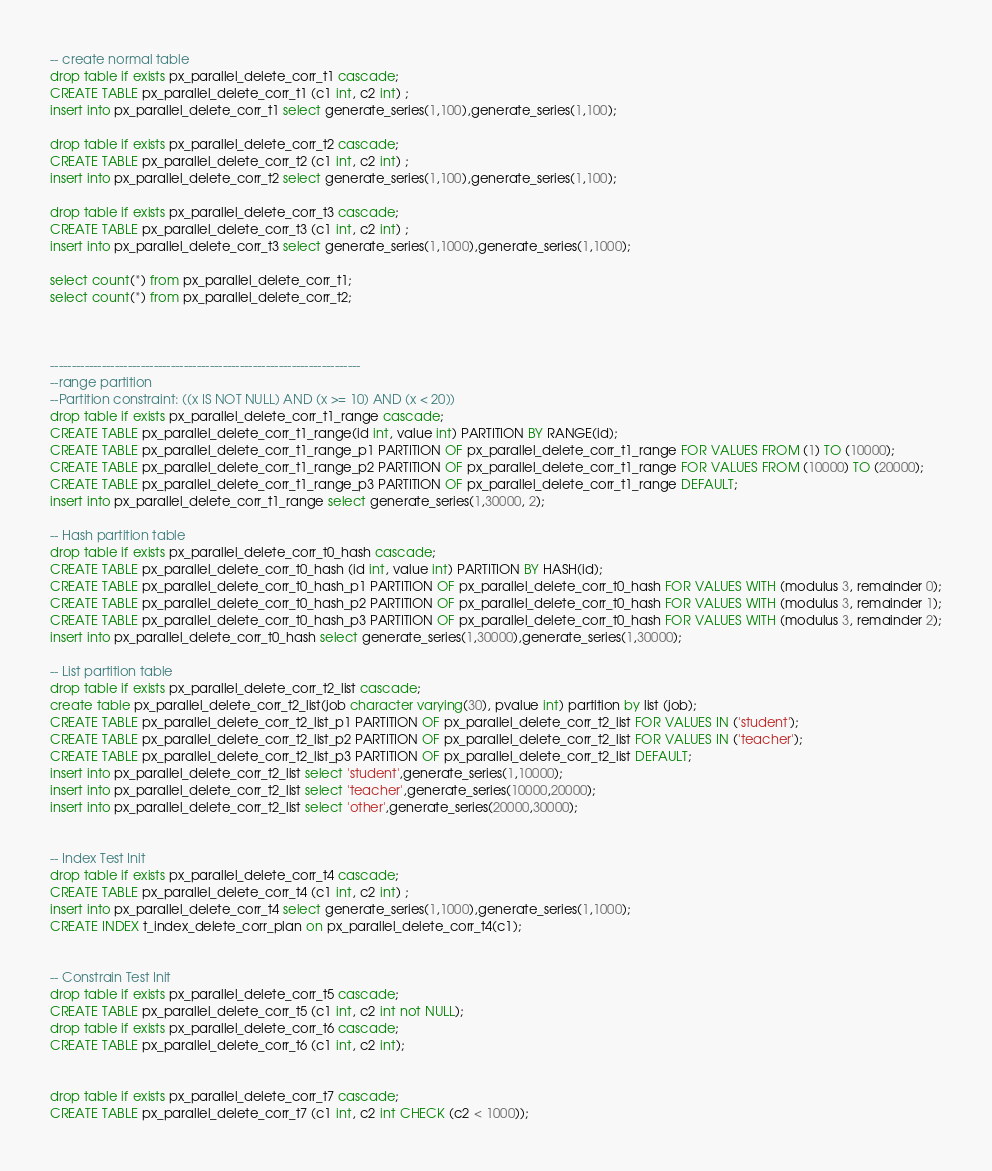Convert code to text. <code><loc_0><loc_0><loc_500><loc_500><_SQL_>-- create normal table
drop table if exists px_parallel_delete_corr_t1 cascade;
CREATE TABLE px_parallel_delete_corr_t1 (c1 int, c2 int) ;
insert into px_parallel_delete_corr_t1 select generate_series(1,100),generate_series(1,100);

drop table if exists px_parallel_delete_corr_t2 cascade;
CREATE TABLE px_parallel_delete_corr_t2 (c1 int, c2 int) ;
insert into px_parallel_delete_corr_t2 select generate_series(1,100),generate_series(1,100);

drop table if exists px_parallel_delete_corr_t3 cascade;
CREATE TABLE px_parallel_delete_corr_t3 (c1 int, c2 int) ;
insert into px_parallel_delete_corr_t3 select generate_series(1,1000),generate_series(1,1000);

select count(*) from px_parallel_delete_corr_t1;
select count(*) from px_parallel_delete_corr_t2;



------------------------------------------------------------------------
--range partition
--Partition constraint: ((x IS NOT NULL) AND (x >= 10) AND (x < 20))
drop table if exists px_parallel_delete_corr_t1_range cascade;
CREATE TABLE px_parallel_delete_corr_t1_range(id int, value int) PARTITION BY RANGE(id);
CREATE TABLE px_parallel_delete_corr_t1_range_p1 PARTITION OF px_parallel_delete_corr_t1_range FOR VALUES FROM (1) TO (10000);
CREATE TABLE px_parallel_delete_corr_t1_range_p2 PARTITION OF px_parallel_delete_corr_t1_range FOR VALUES FROM (10000) TO (20000);
CREATE TABLE px_parallel_delete_corr_t1_range_p3 PARTITION OF px_parallel_delete_corr_t1_range DEFAULT;
insert into px_parallel_delete_corr_t1_range select generate_series(1,30000, 2);

-- Hash partition table
drop table if exists px_parallel_delete_corr_t0_hash cascade;
CREATE TABLE px_parallel_delete_corr_t0_hash (id int, value int) PARTITION BY HASH(id);
CREATE TABLE px_parallel_delete_corr_t0_hash_p1 PARTITION OF px_parallel_delete_corr_t0_hash FOR VALUES WITH (modulus 3, remainder 0);
CREATE TABLE px_parallel_delete_corr_t0_hash_p2 PARTITION OF px_parallel_delete_corr_t0_hash FOR VALUES WITH (modulus 3, remainder 1);
CREATE TABLE px_parallel_delete_corr_t0_hash_p3 PARTITION OF px_parallel_delete_corr_t0_hash FOR VALUES WITH (modulus 3, remainder 2);
insert into px_parallel_delete_corr_t0_hash select generate_series(1,30000),generate_series(1,30000);

-- List partition table
drop table if exists px_parallel_delete_corr_t2_list cascade;
create table px_parallel_delete_corr_t2_list(job character varying(30), pvalue int) partition by list (job);
CREATE TABLE px_parallel_delete_corr_t2_list_p1 PARTITION OF px_parallel_delete_corr_t2_list FOR VALUES IN ('student');
CREATE TABLE px_parallel_delete_corr_t2_list_p2 PARTITION OF px_parallel_delete_corr_t2_list FOR VALUES IN ('teacher');
CREATE TABLE px_parallel_delete_corr_t2_list_p3 PARTITION OF px_parallel_delete_corr_t2_list DEFAULT;
insert into px_parallel_delete_corr_t2_list select 'student',generate_series(1,10000);
insert into px_parallel_delete_corr_t2_list select 'teacher',generate_series(10000,20000);
insert into px_parallel_delete_corr_t2_list select 'other',generate_series(20000,30000);


-- Index Test Init
drop table if exists px_parallel_delete_corr_t4 cascade;
CREATE TABLE px_parallel_delete_corr_t4 (c1 int, c2 int) ;
insert into px_parallel_delete_corr_t4 select generate_series(1,1000),generate_series(1,1000);
CREATE INDEX t_index_delete_corr_plan on px_parallel_delete_corr_t4(c1);


-- Constrain Test Init
drop table if exists px_parallel_delete_corr_t5 cascade;
CREATE TABLE px_parallel_delete_corr_t5 (c1 int, c2 int not NULL);
drop table if exists px_parallel_delete_corr_t6 cascade;
CREATE TABLE px_parallel_delete_corr_t6 (c1 int, c2 int);


drop table if exists px_parallel_delete_corr_t7 cascade;
CREATE TABLE px_parallel_delete_corr_t7 (c1 int, c2 int CHECK (c2 < 1000));
</code> 